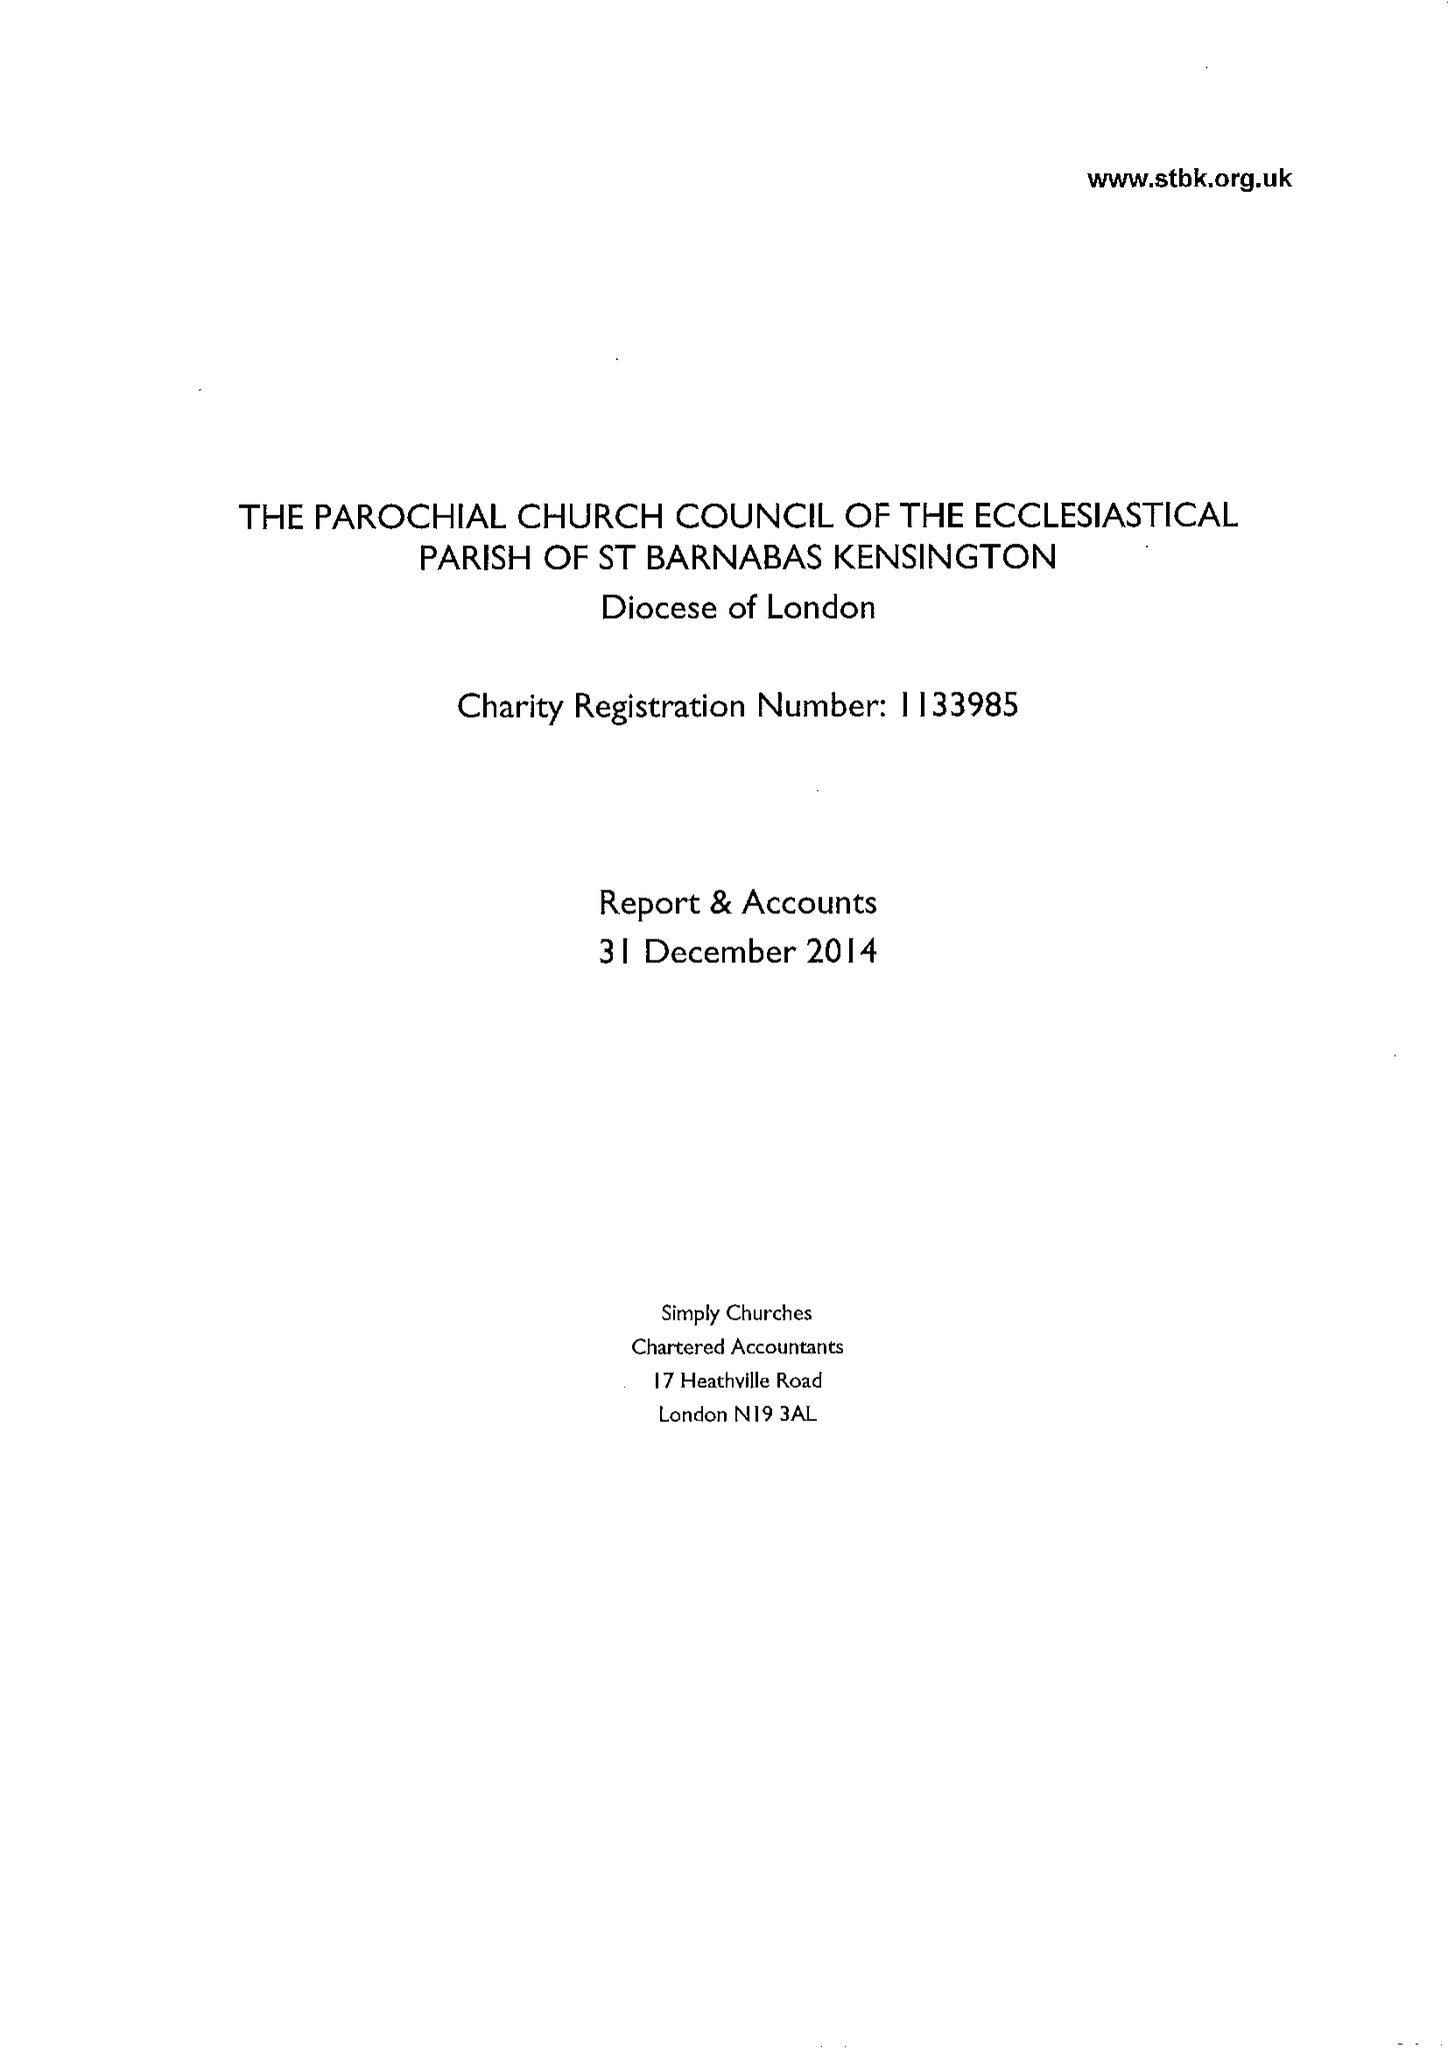What is the value for the report_date?
Answer the question using a single word or phrase. 2014-12-31 